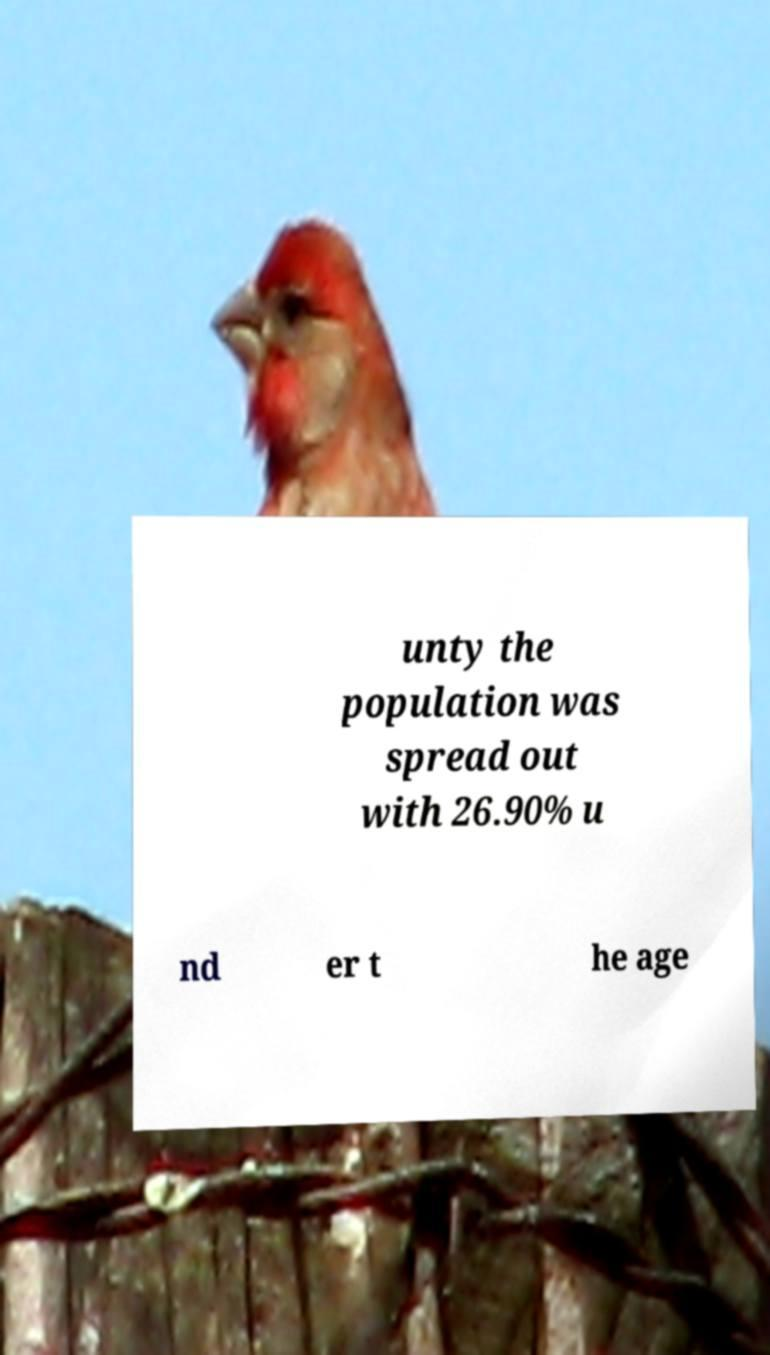Could you extract and type out the text from this image? unty the population was spread out with 26.90% u nd er t he age 